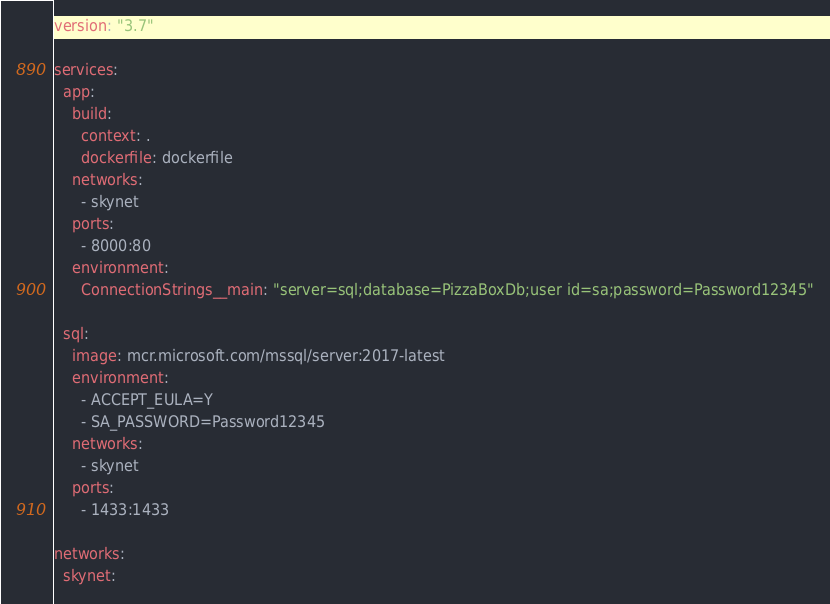<code> <loc_0><loc_0><loc_500><loc_500><_YAML_>
version: "3.7"

services:
  app:
    build:
      context: .
      dockerfile: dockerfile
    networks:
      - skynet
    ports:
      - 8000:80
    environment:
      ConnectionStrings__main: "server=sql;database=PizzaBoxDb;user id=sa;password=Password12345"

  sql:
    image: mcr.microsoft.com/mssql/server:2017-latest
    environment:
      - ACCEPT_EULA=Y
      - SA_PASSWORD=Password12345
    networks:
      - skynet
    ports:
      - 1433:1433

networks:
  skynet:
</code> 